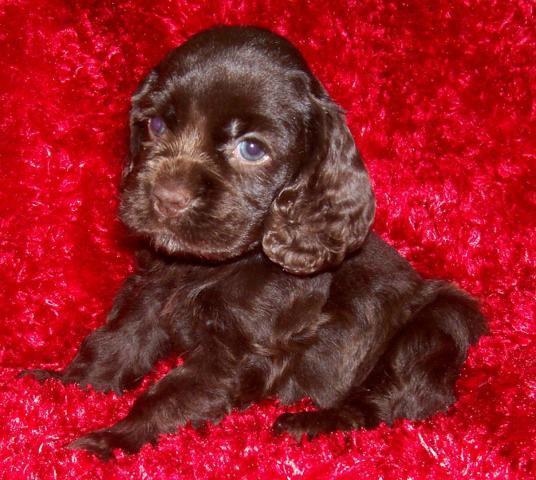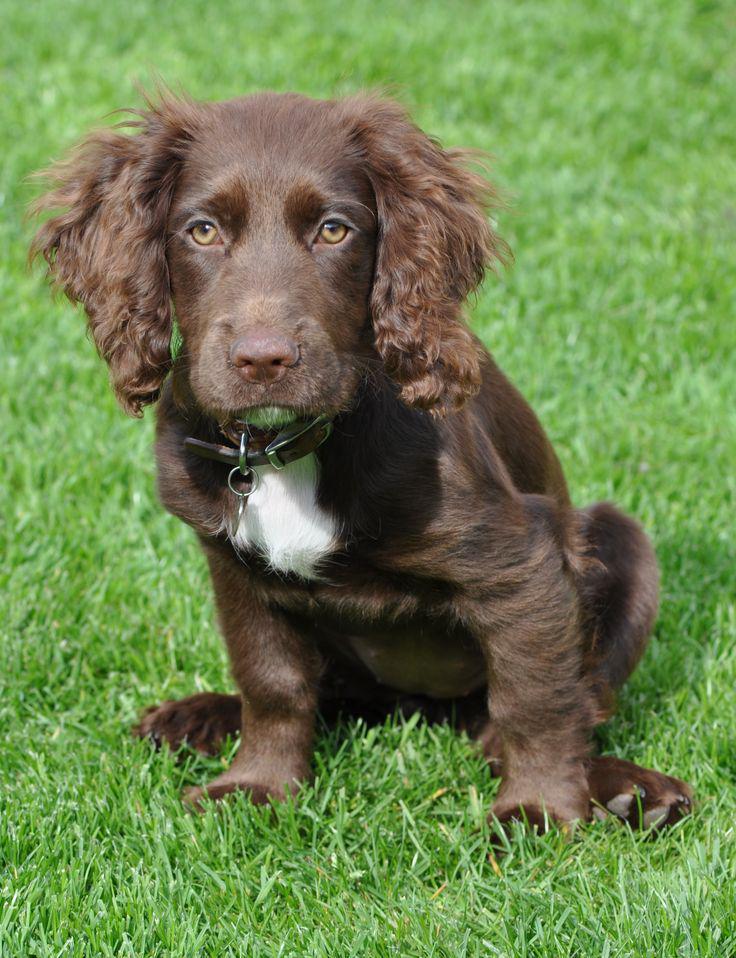The first image is the image on the left, the second image is the image on the right. Examine the images to the left and right. Is the description "One dog is outside in one of the images." accurate? Answer yes or no. Yes. The first image is the image on the left, the second image is the image on the right. Examine the images to the left and right. Is the description "The left image features a very young chocolate-colored spaniel in a sitting position, and the right image features a bigger sitting spaniel." accurate? Answer yes or no. Yes. 